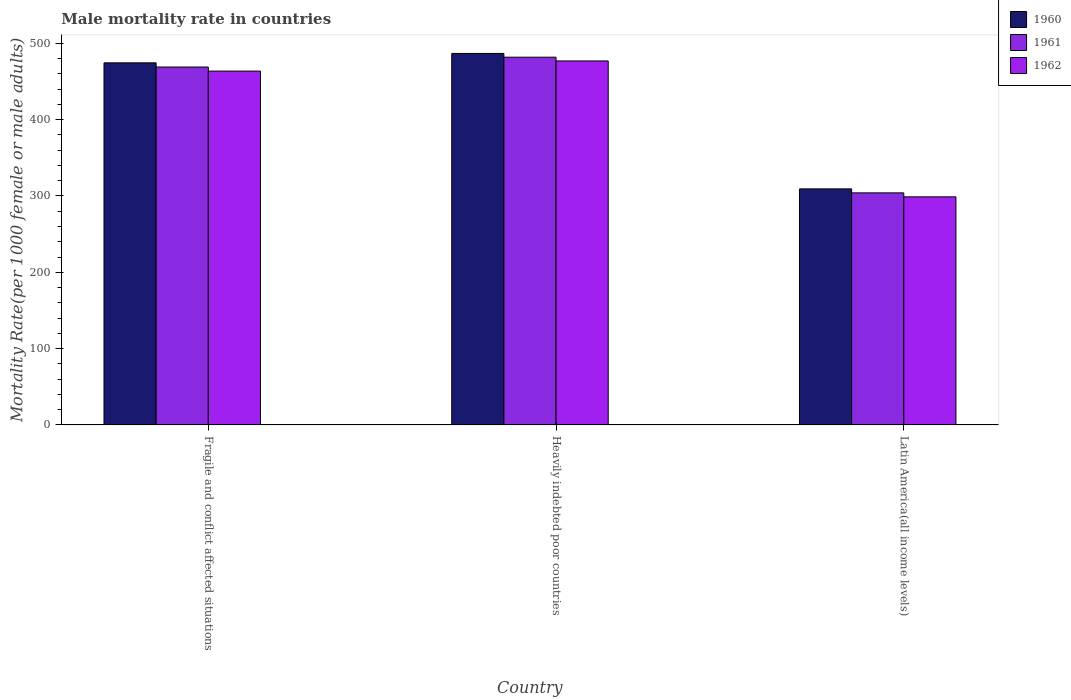How many different coloured bars are there?
Make the answer very short. 3. How many groups of bars are there?
Offer a very short reply. 3. Are the number of bars on each tick of the X-axis equal?
Offer a very short reply. Yes. How many bars are there on the 3rd tick from the left?
Ensure brevity in your answer.  3. How many bars are there on the 2nd tick from the right?
Make the answer very short. 3. What is the label of the 2nd group of bars from the left?
Keep it short and to the point. Heavily indebted poor countries. In how many cases, is the number of bars for a given country not equal to the number of legend labels?
Provide a short and direct response. 0. What is the male mortality rate in 1961 in Fragile and conflict affected situations?
Offer a terse response. 469. Across all countries, what is the maximum male mortality rate in 1962?
Make the answer very short. 476.96. Across all countries, what is the minimum male mortality rate in 1961?
Provide a succinct answer. 304.08. In which country was the male mortality rate in 1961 maximum?
Your response must be concise. Heavily indebted poor countries. In which country was the male mortality rate in 1961 minimum?
Ensure brevity in your answer.  Latin America(all income levels). What is the total male mortality rate in 1960 in the graph?
Give a very brief answer. 1270.57. What is the difference between the male mortality rate in 1961 in Heavily indebted poor countries and that in Latin America(all income levels)?
Offer a terse response. 177.79. What is the difference between the male mortality rate in 1962 in Latin America(all income levels) and the male mortality rate in 1961 in Heavily indebted poor countries?
Ensure brevity in your answer.  -183.01. What is the average male mortality rate in 1961 per country?
Your answer should be compact. 418.32. What is the difference between the male mortality rate of/in 1960 and male mortality rate of/in 1961 in Fragile and conflict affected situations?
Your answer should be compact. 5.48. In how many countries, is the male mortality rate in 1962 greater than 200?
Your answer should be very brief. 3. What is the ratio of the male mortality rate in 1962 in Heavily indebted poor countries to that in Latin America(all income levels)?
Make the answer very short. 1.6. Is the male mortality rate in 1960 in Heavily indebted poor countries less than that in Latin America(all income levels)?
Keep it short and to the point. No. Is the difference between the male mortality rate in 1960 in Heavily indebted poor countries and Latin America(all income levels) greater than the difference between the male mortality rate in 1961 in Heavily indebted poor countries and Latin America(all income levels)?
Your answer should be very brief. No. What is the difference between the highest and the second highest male mortality rate in 1960?
Your answer should be very brief. 165.18. What is the difference between the highest and the lowest male mortality rate in 1962?
Provide a short and direct response. 178.1. In how many countries, is the male mortality rate in 1961 greater than the average male mortality rate in 1961 taken over all countries?
Provide a short and direct response. 2. Is the sum of the male mortality rate in 1961 in Fragile and conflict affected situations and Latin America(all income levels) greater than the maximum male mortality rate in 1962 across all countries?
Provide a short and direct response. Yes. What does the 3rd bar from the left in Fragile and conflict affected situations represents?
Make the answer very short. 1962. What does the 1st bar from the right in Latin America(all income levels) represents?
Provide a short and direct response. 1962. Is it the case that in every country, the sum of the male mortality rate in 1960 and male mortality rate in 1962 is greater than the male mortality rate in 1961?
Offer a very short reply. Yes. How many countries are there in the graph?
Provide a short and direct response. 3. Are the values on the major ticks of Y-axis written in scientific E-notation?
Make the answer very short. No. Does the graph contain any zero values?
Offer a very short reply. No. Does the graph contain grids?
Ensure brevity in your answer.  No. Where does the legend appear in the graph?
Offer a very short reply. Top right. How many legend labels are there?
Your response must be concise. 3. How are the legend labels stacked?
Ensure brevity in your answer.  Vertical. What is the title of the graph?
Offer a terse response. Male mortality rate in countries. Does "1990" appear as one of the legend labels in the graph?
Ensure brevity in your answer.  No. What is the label or title of the Y-axis?
Make the answer very short. Mortality Rate(per 1000 female or male adults). What is the Mortality Rate(per 1000 female or male adults) in 1960 in Fragile and conflict affected situations?
Give a very brief answer. 474.48. What is the Mortality Rate(per 1000 female or male adults) in 1961 in Fragile and conflict affected situations?
Your answer should be compact. 469. What is the Mortality Rate(per 1000 female or male adults) in 1962 in Fragile and conflict affected situations?
Keep it short and to the point. 463.65. What is the Mortality Rate(per 1000 female or male adults) in 1960 in Heavily indebted poor countries?
Make the answer very short. 486.79. What is the Mortality Rate(per 1000 female or male adults) of 1961 in Heavily indebted poor countries?
Your answer should be very brief. 481.87. What is the Mortality Rate(per 1000 female or male adults) of 1962 in Heavily indebted poor countries?
Your response must be concise. 476.96. What is the Mortality Rate(per 1000 female or male adults) of 1960 in Latin America(all income levels)?
Your answer should be compact. 309.3. What is the Mortality Rate(per 1000 female or male adults) in 1961 in Latin America(all income levels)?
Your answer should be compact. 304.08. What is the Mortality Rate(per 1000 female or male adults) in 1962 in Latin America(all income levels)?
Provide a succinct answer. 298.86. Across all countries, what is the maximum Mortality Rate(per 1000 female or male adults) of 1960?
Provide a succinct answer. 486.79. Across all countries, what is the maximum Mortality Rate(per 1000 female or male adults) of 1961?
Provide a succinct answer. 481.87. Across all countries, what is the maximum Mortality Rate(per 1000 female or male adults) of 1962?
Your response must be concise. 476.96. Across all countries, what is the minimum Mortality Rate(per 1000 female or male adults) in 1960?
Your response must be concise. 309.3. Across all countries, what is the minimum Mortality Rate(per 1000 female or male adults) of 1961?
Offer a very short reply. 304.08. Across all countries, what is the minimum Mortality Rate(per 1000 female or male adults) in 1962?
Keep it short and to the point. 298.86. What is the total Mortality Rate(per 1000 female or male adults) of 1960 in the graph?
Your answer should be compact. 1270.57. What is the total Mortality Rate(per 1000 female or male adults) in 1961 in the graph?
Offer a very short reply. 1254.95. What is the total Mortality Rate(per 1000 female or male adults) of 1962 in the graph?
Provide a short and direct response. 1239.47. What is the difference between the Mortality Rate(per 1000 female or male adults) of 1960 in Fragile and conflict affected situations and that in Heavily indebted poor countries?
Your answer should be compact. -12.31. What is the difference between the Mortality Rate(per 1000 female or male adults) of 1961 in Fragile and conflict affected situations and that in Heavily indebted poor countries?
Ensure brevity in your answer.  -12.88. What is the difference between the Mortality Rate(per 1000 female or male adults) in 1962 in Fragile and conflict affected situations and that in Heavily indebted poor countries?
Make the answer very short. -13.31. What is the difference between the Mortality Rate(per 1000 female or male adults) in 1960 in Fragile and conflict affected situations and that in Latin America(all income levels)?
Keep it short and to the point. 165.18. What is the difference between the Mortality Rate(per 1000 female or male adults) of 1961 in Fragile and conflict affected situations and that in Latin America(all income levels)?
Provide a short and direct response. 164.92. What is the difference between the Mortality Rate(per 1000 female or male adults) in 1962 in Fragile and conflict affected situations and that in Latin America(all income levels)?
Provide a short and direct response. 164.79. What is the difference between the Mortality Rate(per 1000 female or male adults) in 1960 in Heavily indebted poor countries and that in Latin America(all income levels)?
Your answer should be compact. 177.49. What is the difference between the Mortality Rate(per 1000 female or male adults) in 1961 in Heavily indebted poor countries and that in Latin America(all income levels)?
Make the answer very short. 177.79. What is the difference between the Mortality Rate(per 1000 female or male adults) of 1962 in Heavily indebted poor countries and that in Latin America(all income levels)?
Your answer should be very brief. 178.1. What is the difference between the Mortality Rate(per 1000 female or male adults) in 1960 in Fragile and conflict affected situations and the Mortality Rate(per 1000 female or male adults) in 1961 in Heavily indebted poor countries?
Provide a succinct answer. -7.39. What is the difference between the Mortality Rate(per 1000 female or male adults) in 1960 in Fragile and conflict affected situations and the Mortality Rate(per 1000 female or male adults) in 1962 in Heavily indebted poor countries?
Provide a short and direct response. -2.48. What is the difference between the Mortality Rate(per 1000 female or male adults) of 1961 in Fragile and conflict affected situations and the Mortality Rate(per 1000 female or male adults) of 1962 in Heavily indebted poor countries?
Give a very brief answer. -7.96. What is the difference between the Mortality Rate(per 1000 female or male adults) of 1960 in Fragile and conflict affected situations and the Mortality Rate(per 1000 female or male adults) of 1961 in Latin America(all income levels)?
Make the answer very short. 170.4. What is the difference between the Mortality Rate(per 1000 female or male adults) in 1960 in Fragile and conflict affected situations and the Mortality Rate(per 1000 female or male adults) in 1962 in Latin America(all income levels)?
Provide a succinct answer. 175.62. What is the difference between the Mortality Rate(per 1000 female or male adults) of 1961 in Fragile and conflict affected situations and the Mortality Rate(per 1000 female or male adults) of 1962 in Latin America(all income levels)?
Provide a short and direct response. 170.13. What is the difference between the Mortality Rate(per 1000 female or male adults) in 1960 in Heavily indebted poor countries and the Mortality Rate(per 1000 female or male adults) in 1961 in Latin America(all income levels)?
Keep it short and to the point. 182.71. What is the difference between the Mortality Rate(per 1000 female or male adults) of 1960 in Heavily indebted poor countries and the Mortality Rate(per 1000 female or male adults) of 1962 in Latin America(all income levels)?
Provide a short and direct response. 187.93. What is the difference between the Mortality Rate(per 1000 female or male adults) in 1961 in Heavily indebted poor countries and the Mortality Rate(per 1000 female or male adults) in 1962 in Latin America(all income levels)?
Provide a succinct answer. 183.01. What is the average Mortality Rate(per 1000 female or male adults) of 1960 per country?
Your response must be concise. 423.52. What is the average Mortality Rate(per 1000 female or male adults) of 1961 per country?
Provide a succinct answer. 418.32. What is the average Mortality Rate(per 1000 female or male adults) of 1962 per country?
Keep it short and to the point. 413.16. What is the difference between the Mortality Rate(per 1000 female or male adults) in 1960 and Mortality Rate(per 1000 female or male adults) in 1961 in Fragile and conflict affected situations?
Your response must be concise. 5.48. What is the difference between the Mortality Rate(per 1000 female or male adults) of 1960 and Mortality Rate(per 1000 female or male adults) of 1962 in Fragile and conflict affected situations?
Give a very brief answer. 10.83. What is the difference between the Mortality Rate(per 1000 female or male adults) in 1961 and Mortality Rate(per 1000 female or male adults) in 1962 in Fragile and conflict affected situations?
Make the answer very short. 5.35. What is the difference between the Mortality Rate(per 1000 female or male adults) in 1960 and Mortality Rate(per 1000 female or male adults) in 1961 in Heavily indebted poor countries?
Your response must be concise. 4.92. What is the difference between the Mortality Rate(per 1000 female or male adults) of 1960 and Mortality Rate(per 1000 female or male adults) of 1962 in Heavily indebted poor countries?
Keep it short and to the point. 9.83. What is the difference between the Mortality Rate(per 1000 female or male adults) of 1961 and Mortality Rate(per 1000 female or male adults) of 1962 in Heavily indebted poor countries?
Ensure brevity in your answer.  4.91. What is the difference between the Mortality Rate(per 1000 female or male adults) in 1960 and Mortality Rate(per 1000 female or male adults) in 1961 in Latin America(all income levels)?
Keep it short and to the point. 5.22. What is the difference between the Mortality Rate(per 1000 female or male adults) in 1960 and Mortality Rate(per 1000 female or male adults) in 1962 in Latin America(all income levels)?
Your answer should be very brief. 10.44. What is the difference between the Mortality Rate(per 1000 female or male adults) of 1961 and Mortality Rate(per 1000 female or male adults) of 1962 in Latin America(all income levels)?
Provide a succinct answer. 5.21. What is the ratio of the Mortality Rate(per 1000 female or male adults) in 1960 in Fragile and conflict affected situations to that in Heavily indebted poor countries?
Your answer should be compact. 0.97. What is the ratio of the Mortality Rate(per 1000 female or male adults) in 1961 in Fragile and conflict affected situations to that in Heavily indebted poor countries?
Make the answer very short. 0.97. What is the ratio of the Mortality Rate(per 1000 female or male adults) in 1962 in Fragile and conflict affected situations to that in Heavily indebted poor countries?
Offer a terse response. 0.97. What is the ratio of the Mortality Rate(per 1000 female or male adults) in 1960 in Fragile and conflict affected situations to that in Latin America(all income levels)?
Provide a succinct answer. 1.53. What is the ratio of the Mortality Rate(per 1000 female or male adults) of 1961 in Fragile and conflict affected situations to that in Latin America(all income levels)?
Provide a short and direct response. 1.54. What is the ratio of the Mortality Rate(per 1000 female or male adults) of 1962 in Fragile and conflict affected situations to that in Latin America(all income levels)?
Give a very brief answer. 1.55. What is the ratio of the Mortality Rate(per 1000 female or male adults) of 1960 in Heavily indebted poor countries to that in Latin America(all income levels)?
Provide a short and direct response. 1.57. What is the ratio of the Mortality Rate(per 1000 female or male adults) of 1961 in Heavily indebted poor countries to that in Latin America(all income levels)?
Give a very brief answer. 1.58. What is the ratio of the Mortality Rate(per 1000 female or male adults) in 1962 in Heavily indebted poor countries to that in Latin America(all income levels)?
Your answer should be compact. 1.6. What is the difference between the highest and the second highest Mortality Rate(per 1000 female or male adults) of 1960?
Ensure brevity in your answer.  12.31. What is the difference between the highest and the second highest Mortality Rate(per 1000 female or male adults) in 1961?
Ensure brevity in your answer.  12.88. What is the difference between the highest and the second highest Mortality Rate(per 1000 female or male adults) in 1962?
Ensure brevity in your answer.  13.31. What is the difference between the highest and the lowest Mortality Rate(per 1000 female or male adults) of 1960?
Offer a terse response. 177.49. What is the difference between the highest and the lowest Mortality Rate(per 1000 female or male adults) in 1961?
Ensure brevity in your answer.  177.79. What is the difference between the highest and the lowest Mortality Rate(per 1000 female or male adults) of 1962?
Ensure brevity in your answer.  178.1. 